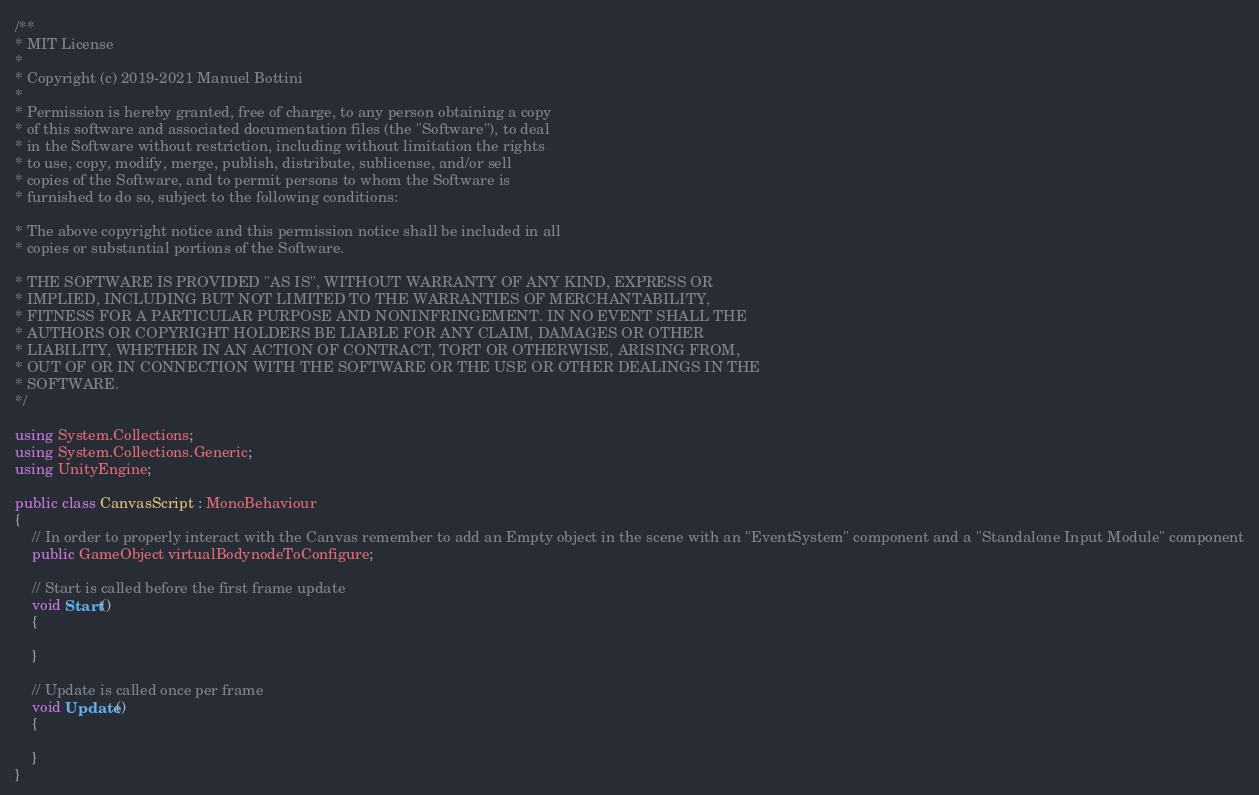Convert code to text. <code><loc_0><loc_0><loc_500><loc_500><_C#_>/**
* MIT License
* 
* Copyright (c) 2019-2021 Manuel Bottini
*
* Permission is hereby granted, free of charge, to any person obtaining a copy
* of this software and associated documentation files (the "Software"), to deal
* in the Software without restriction, including without limitation the rights
* to use, copy, modify, merge, publish, distribute, sublicense, and/or sell
* copies of the Software, and to permit persons to whom the Software is
* furnished to do so, subject to the following conditions:

* The above copyright notice and this permission notice shall be included in all
* copies or substantial portions of the Software.

* THE SOFTWARE IS PROVIDED "AS IS", WITHOUT WARRANTY OF ANY KIND, EXPRESS OR
* IMPLIED, INCLUDING BUT NOT LIMITED TO THE WARRANTIES OF MERCHANTABILITY,
* FITNESS FOR A PARTICULAR PURPOSE AND NONINFRINGEMENT. IN NO EVENT SHALL THE
* AUTHORS OR COPYRIGHT HOLDERS BE LIABLE FOR ANY CLAIM, DAMAGES OR OTHER
* LIABILITY, WHETHER IN AN ACTION OF CONTRACT, TORT OR OTHERWISE, ARISING FROM,
* OUT OF OR IN CONNECTION WITH THE SOFTWARE OR THE USE OR OTHER DEALINGS IN THE
* SOFTWARE.
*/

using System.Collections;
using System.Collections.Generic;
using UnityEngine;

public class CanvasScript : MonoBehaviour
{
	// In order to properly interact with the Canvas remember to add an Empty object in the scene with an "EventSystem" component and a "Standalone Input Module" component
	public GameObject virtualBodynodeToConfigure;
	
    // Start is called before the first frame update
    void Start()
    {
        
    }

    // Update is called once per frame
    void Update()
    {
        
    }
}
</code> 